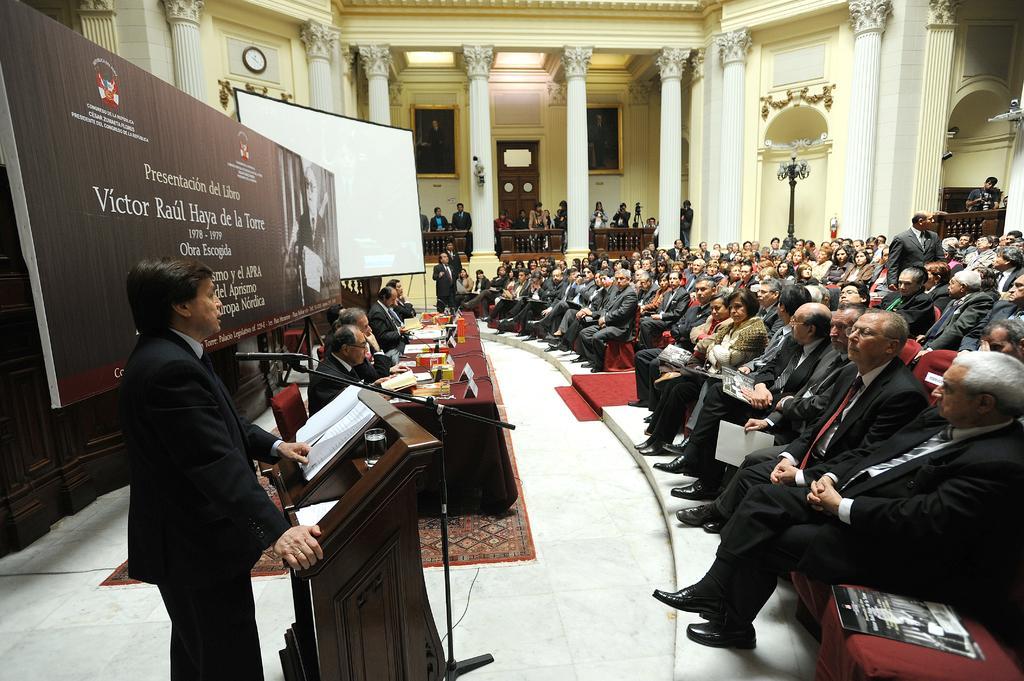Please provide a concise description of this image. In this picture we can see a group of people, some people are sitting on chairs, some people are standing, here we can see a table, name boards, papers, podium, mic and some objects and in the background we can see a poster, projector screen, pillars, wall, fence, clock, windows, door. 